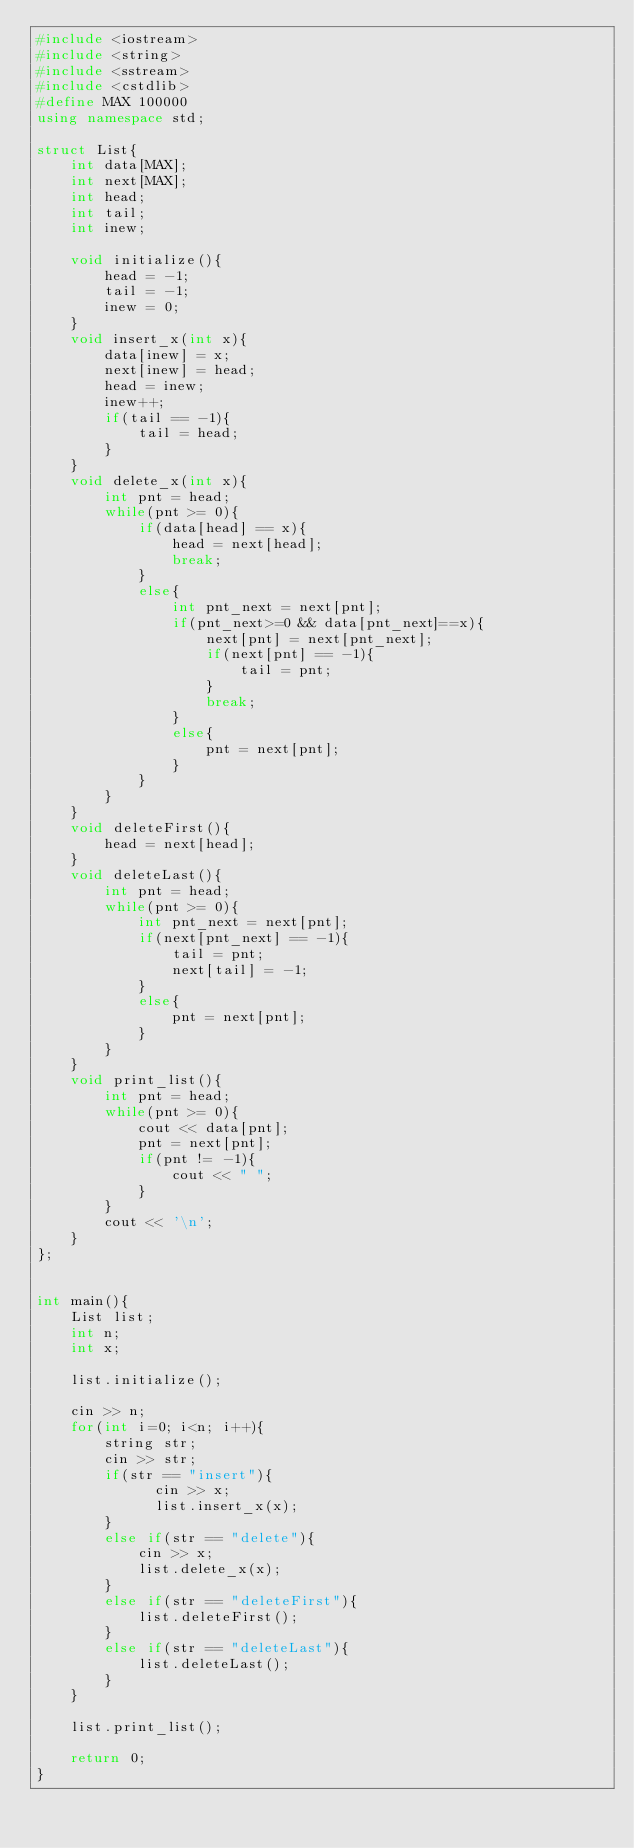Convert code to text. <code><loc_0><loc_0><loc_500><loc_500><_C++_>#include <iostream>
#include <string>
#include <sstream>
#include <cstdlib>
#define MAX 100000
using namespace std;

struct List{
    int data[MAX];
    int next[MAX];
    int head;
    int tail;
    int inew;

    void initialize(){
        head = -1;
        tail = -1;
        inew = 0;
    }
    void insert_x(int x){
        data[inew] = x;
        next[inew] = head;
        head = inew;
        inew++;
        if(tail == -1){
            tail = head;
        }
    }
    void delete_x(int x){
        int pnt = head;
        while(pnt >= 0){
            if(data[head] == x){
                head = next[head];
                break;
            }
            else{
                int pnt_next = next[pnt];
                if(pnt_next>=0 && data[pnt_next]==x){
                    next[pnt] = next[pnt_next];
                    if(next[pnt] == -1){
                        tail = pnt;
                    }
                    break;
                }
                else{
                    pnt = next[pnt];
                }
            }
        }
    }
    void deleteFirst(){
        head = next[head];
    }
    void deleteLast(){
        int pnt = head;
        while(pnt >= 0){
            int pnt_next = next[pnt];
            if(next[pnt_next] == -1){
                tail = pnt;
                next[tail] = -1;
            }
            else{
                pnt = next[pnt];
            }
        }
    }
    void print_list(){
        int pnt = head;
        while(pnt >= 0){
            cout << data[pnt];
            pnt = next[pnt];
            if(pnt != -1){
                cout << " ";
            }
        }
        cout << '\n';
    }
};


int main(){
    List list;  
    int n;
    int x;

    list.initialize();

    cin >> n;
    for(int i=0; i<n; i++){
        string str;
        cin >> str;
        if(str == "insert"){
              cin >> x;
              list.insert_x(x);
        }
        else if(str == "delete"){
            cin >> x;
            list.delete_x(x);
        }
        else if(str == "deleteFirst"){
            list.deleteFirst();
        }
        else if(str == "deleteLast"){
            list.deleteLast();
        }
    }

    list.print_list();

    return 0;
}
</code> 